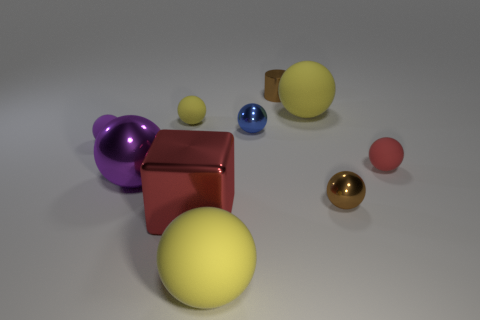How many other things are there of the same material as the small purple ball?
Give a very brief answer. 4. There is a small rubber thing that is right of the brown object that is left of the brown object that is in front of the small red sphere; what is its color?
Your answer should be very brief. Red. There is a brown metal object behind the large purple shiny sphere behind the red metallic block; what is its shape?
Your answer should be compact. Cylinder. Are there more brown shiny things that are on the right side of the brown metallic ball than cylinders?
Offer a terse response. No. There is a brown metallic object that is in front of the tiny yellow rubber ball; does it have the same shape as the red rubber object?
Your answer should be compact. Yes. Is there a big red object that has the same shape as the purple matte object?
Your answer should be very brief. No. How many objects are tiny brown things right of the metal cylinder or tiny matte things?
Ensure brevity in your answer.  4. Are there more tiny gray cubes than small purple matte things?
Your answer should be compact. No. Are there any other cylinders of the same size as the brown cylinder?
Keep it short and to the point. No. What number of objects are yellow matte things on the right side of the tiny cylinder or matte balls on the left side of the tiny yellow matte object?
Provide a short and direct response. 2. 